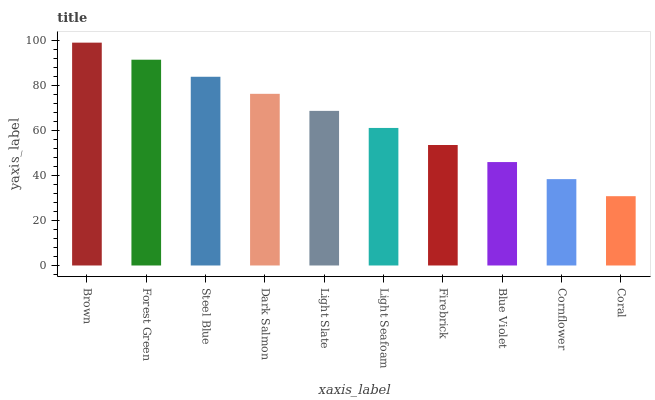Is Coral the minimum?
Answer yes or no. Yes. Is Brown the maximum?
Answer yes or no. Yes. Is Forest Green the minimum?
Answer yes or no. No. Is Forest Green the maximum?
Answer yes or no. No. Is Brown greater than Forest Green?
Answer yes or no. Yes. Is Forest Green less than Brown?
Answer yes or no. Yes. Is Forest Green greater than Brown?
Answer yes or no. No. Is Brown less than Forest Green?
Answer yes or no. No. Is Light Slate the high median?
Answer yes or no. Yes. Is Light Seafoam the low median?
Answer yes or no. Yes. Is Firebrick the high median?
Answer yes or no. No. Is Steel Blue the low median?
Answer yes or no. No. 